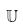<formula> <loc_0><loc_0><loc_500><loc_500>\mathbb { U }</formula> 